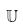<formula> <loc_0><loc_0><loc_500><loc_500>\mathbb { U }</formula> 